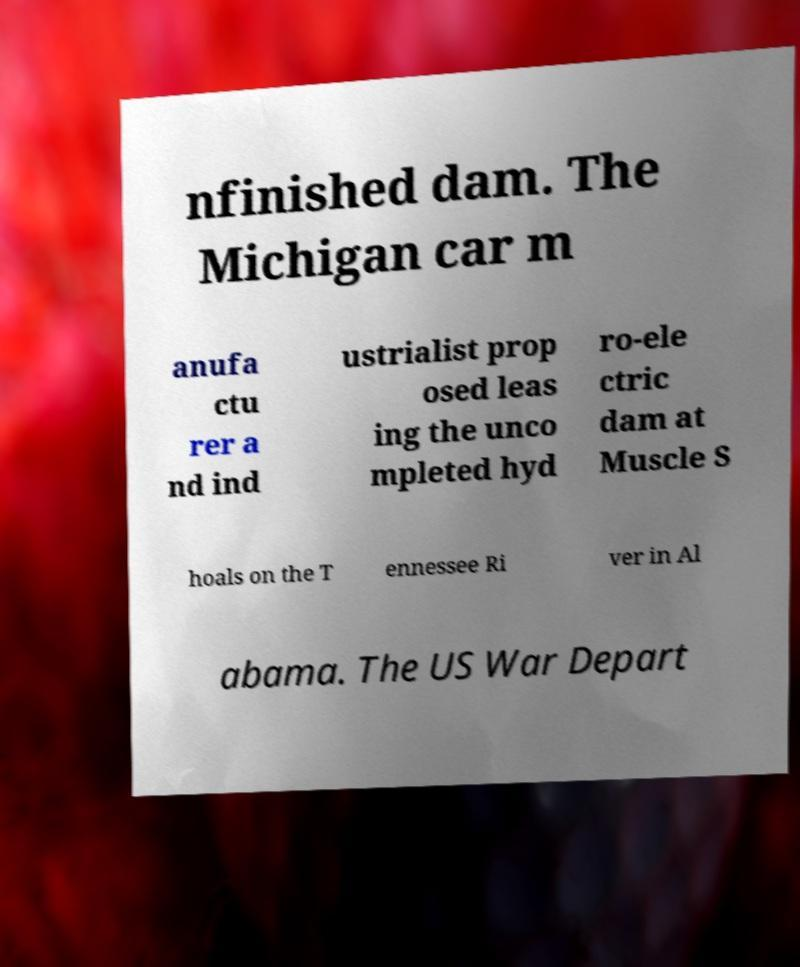Can you accurately transcribe the text from the provided image for me? nfinished dam. The Michigan car m anufa ctu rer a nd ind ustrialist prop osed leas ing the unco mpleted hyd ro-ele ctric dam at Muscle S hoals on the T ennessee Ri ver in Al abama. The US War Depart 